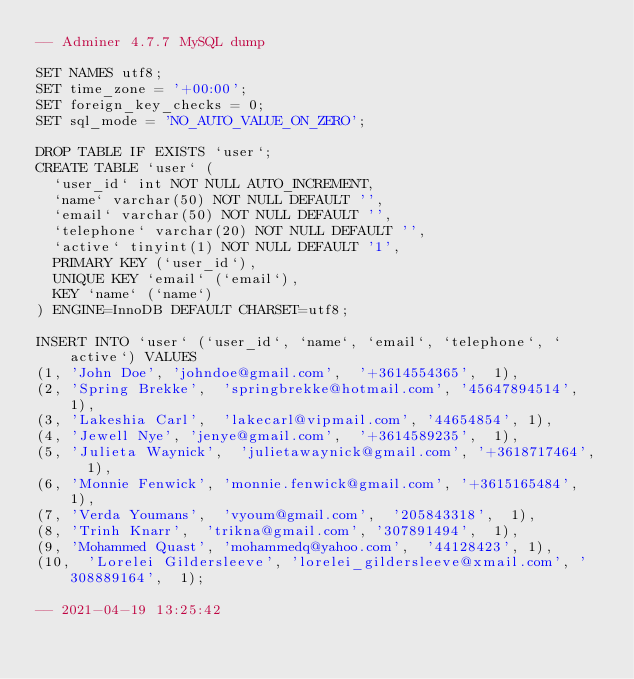Convert code to text. <code><loc_0><loc_0><loc_500><loc_500><_SQL_>-- Adminer 4.7.7 MySQL dump

SET NAMES utf8;
SET time_zone = '+00:00';
SET foreign_key_checks = 0;
SET sql_mode = 'NO_AUTO_VALUE_ON_ZERO';

DROP TABLE IF EXISTS `user`;
CREATE TABLE `user` (
  `user_id` int NOT NULL AUTO_INCREMENT,
  `name` varchar(50) NOT NULL DEFAULT '',
  `email` varchar(50) NOT NULL DEFAULT '',
  `telephone` varchar(20) NOT NULL DEFAULT '',
  `active` tinyint(1) NOT NULL DEFAULT '1',
  PRIMARY KEY (`user_id`),
  UNIQUE KEY `email` (`email`),
  KEY `name` (`name`)
) ENGINE=InnoDB DEFAULT CHARSET=utf8;

INSERT INTO `user` (`user_id`, `name`, `email`, `telephone`, `active`) VALUES
(1,	'John Doe',	'johndoe@gmail.com',	'+3614554365',	1),
(2,	'Spring Brekke',	'springbrekke@hotmail.com',	'45647894514',	1),
(3,	'Lakeshia Carl',	'lakecarl@vipmail.com',	'44654854',	1),
(4,	'Jewell Nye',	'jenye@gmail.com',	'+3614589235',	1),
(5,	'Julieta Waynick',	'julietawaynick@gmail.com',	'+3618717464',	1),
(6,	'Monnie Fenwick',	'monnie.fenwick@gmail.com',	'+3615165484',	1),
(7,	'Verda Youmans',	'vyoum@gmail.com',	'205843318',	1),
(8,	'Trinh Knarr',	'trikna@gmail.com',	'307891494',	1),
(9,	'Mohammed Quast',	'mohammedq@yahoo.com',	'44128423',	1),
(10,	'Lorelei Gildersleeve',	'lorelei_gildersleeve@xmail.com',	'308889164',	1);

-- 2021-04-19 13:25:42
</code> 